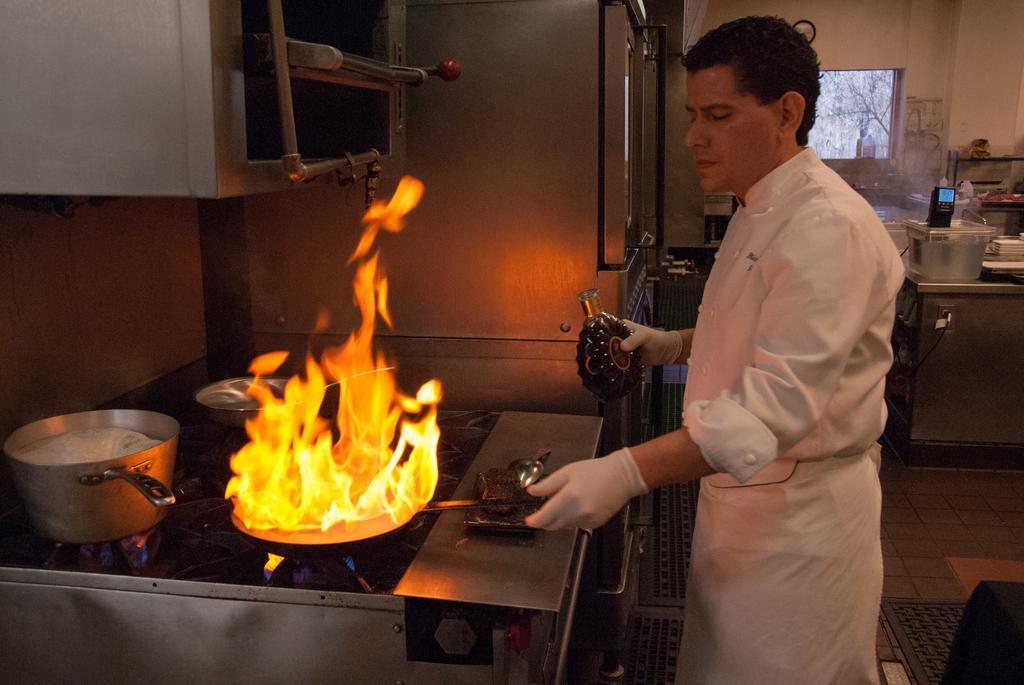Can you describe this image briefly? In the picture I can see a fire. In the middle of the image I can see a person holding the object. I can see the stove and bowls. In the background, I can see a window and some other objects. 